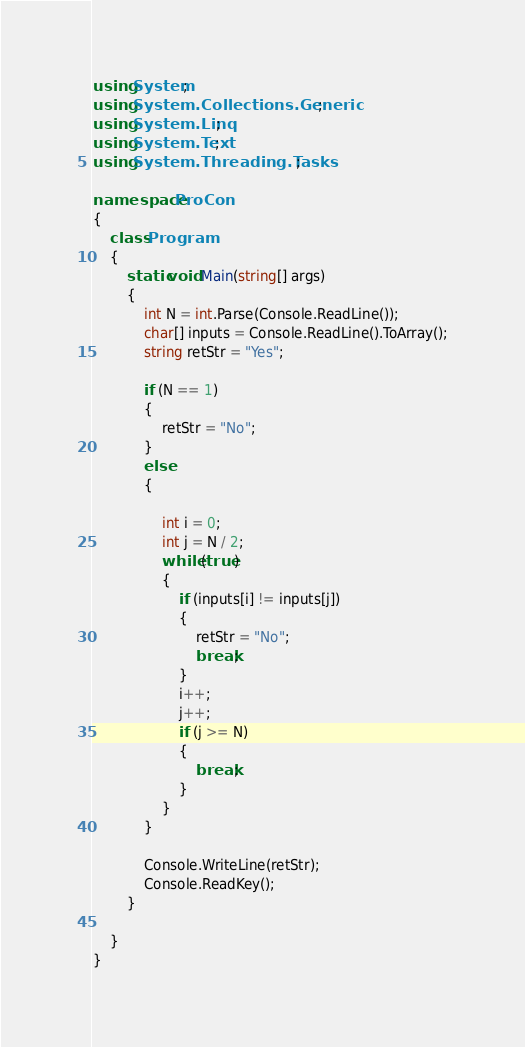Convert code to text. <code><loc_0><loc_0><loc_500><loc_500><_C#_>using System;
using System.Collections.Generic;
using System.Linq;
using System.Text;
using System.Threading.Tasks;

namespace ProCon
{
    class Program
    {
        static void Main(string[] args)
        {
            int N = int.Parse(Console.ReadLine());
            char[] inputs = Console.ReadLine().ToArray();
            string retStr = "Yes";

            if (N == 1)
            {
                retStr = "No";
            }
            else 
            {

                int i = 0;
                int j = N / 2;
                while (true)
                {
                    if (inputs[i] != inputs[j])
                    {
                        retStr = "No";
                        break;
                    }
                    i++;
                    j++;
                    if (j >= N)
                    {
                        break;
                    }
                }
            }

            Console.WriteLine(retStr);
            Console.ReadKey();
        }

    }
}
</code> 